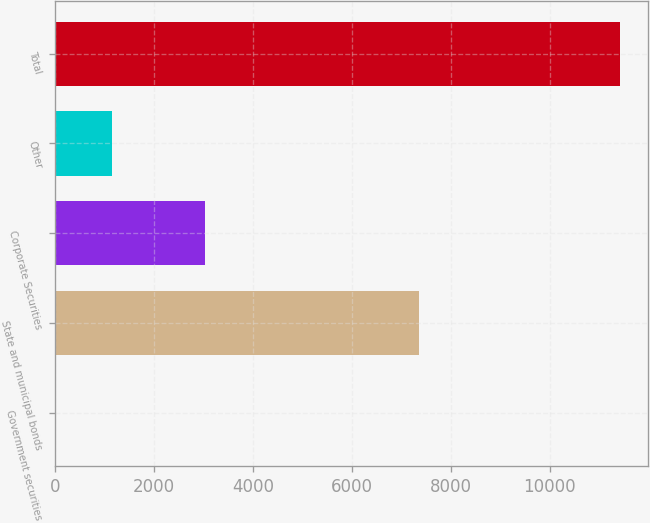<chart> <loc_0><loc_0><loc_500><loc_500><bar_chart><fcel>Government securities<fcel>State and municipal bonds<fcel>Corporate Securities<fcel>Other<fcel>Total<nl><fcel>3.45<fcel>7368<fcel>3031<fcel>1144.81<fcel>11417<nl></chart> 